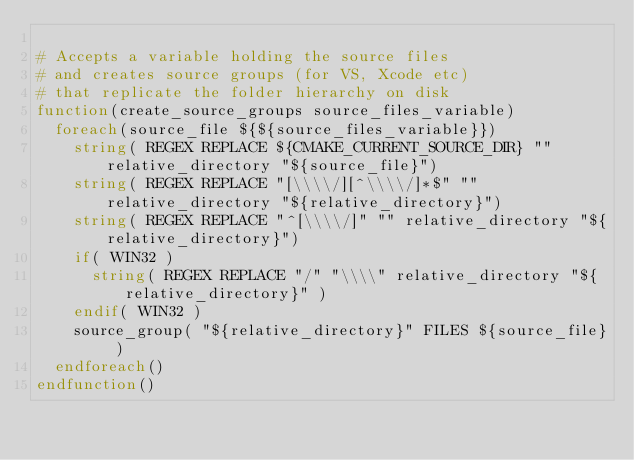<code> <loc_0><loc_0><loc_500><loc_500><_CMake_>
# Accepts a variable holding the source files
# and creates source groups (for VS, Xcode etc)
# that replicate the folder hierarchy on disk
function(create_source_groups source_files_variable)
	foreach(source_file ${${source_files_variable}})
		string( REGEX REPLACE ${CMAKE_CURRENT_SOURCE_DIR} "" relative_directory "${source_file}")
		string( REGEX REPLACE "[\\\\/][^\\\\/]*$" "" relative_directory "${relative_directory}")
		string( REGEX REPLACE "^[\\\\/]" "" relative_directory "${relative_directory}")
		if( WIN32 )
			string( REGEX REPLACE "/" "\\\\" relative_directory "${relative_directory}" )
		endif( WIN32 )
		source_group( "${relative_directory}" FILES ${source_file} )
	endforeach()
endfunction()
</code> 